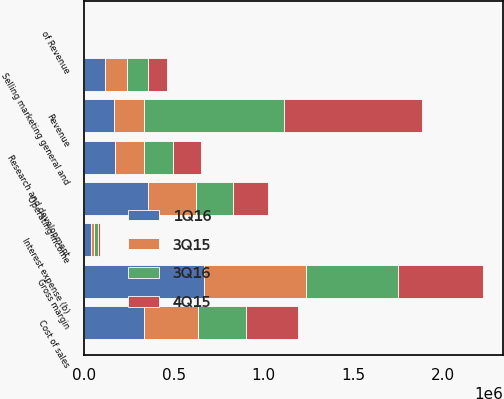Convert chart to OTSL. <chart><loc_0><loc_0><loc_500><loc_500><stacked_bar_chart><ecel><fcel>Revenue<fcel>Cost of sales<fcel>Gross margin<fcel>of Revenue<fcel>Research and development<fcel>Selling marketing general and<fcel>Operating income<fcel>Interest expense (b)<nl><fcel>1Q16<fcel>168076<fcel>336936<fcel>666687<fcel>66.4<fcel>172926<fcel>118881<fcel>356981<fcel>38764<nl><fcel>3Q15<fcel>168076<fcel>297301<fcel>572290<fcel>65.8<fcel>163227<fcel>122909<fcel>268707<fcel>18476<nl><fcel>3Q16<fcel>778766<fcel>267863<fcel>510903<fcel>65.6<fcel>160235<fcel>112186<fcel>207379<fcel>18455<nl><fcel>4Q15<fcel>769429<fcel>292136<fcel>477293<fcel>62<fcel>157428<fcel>107462<fcel>195045<fcel>13062<nl></chart> 